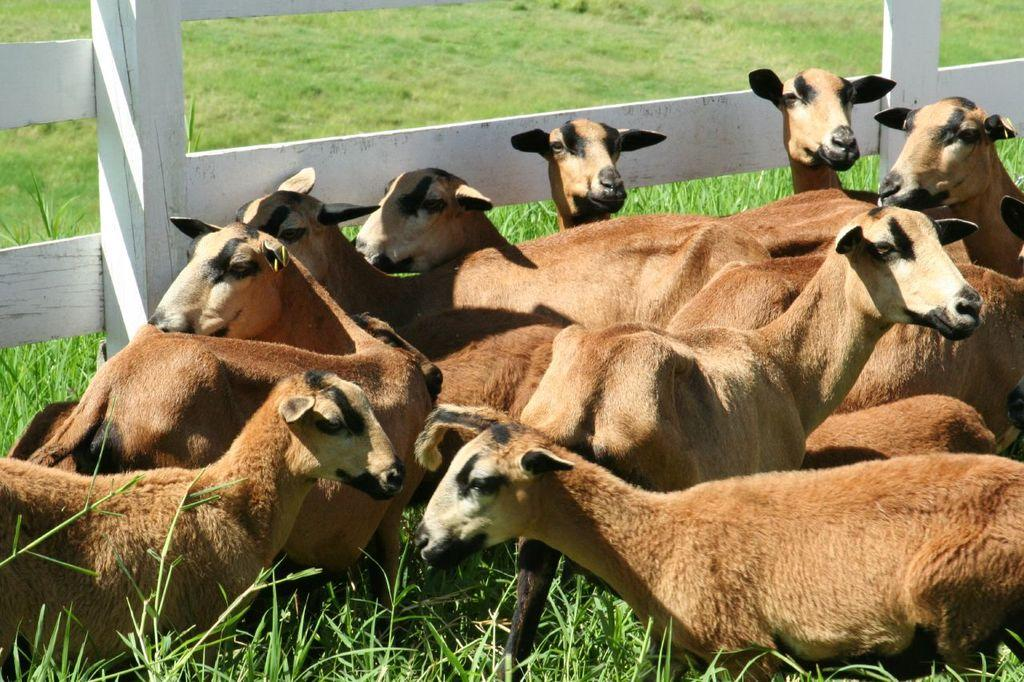What types of living organisms are in the front of the image? There are animals in the front of the image. What is located in the center of the image? There is a wooden fence in the center of the image. What type of vegetation is visible in the background of the image? There is grass on the ground in the background of the image. How many shoes can be seen hanging on the wooden fence in the image? There are no shoes present in the image; it features animals, a wooden fence, and grass. What type of eggs are being laid by the animals in the image? There is no indication in the image that the animals are laying eggs. 